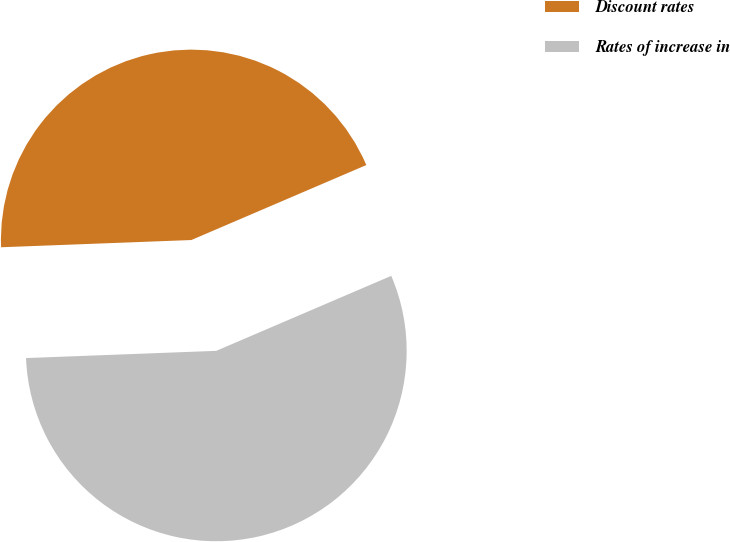Convert chart to OTSL. <chart><loc_0><loc_0><loc_500><loc_500><pie_chart><fcel>Discount rates<fcel>Rates of increase in<nl><fcel>44.16%<fcel>55.84%<nl></chart> 